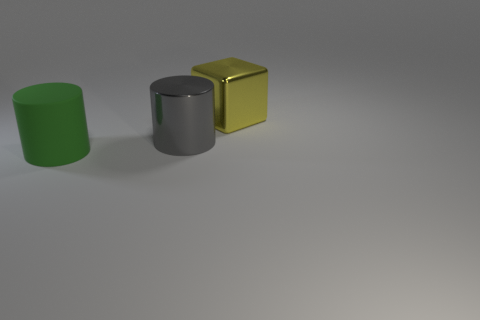There is a metallic object that is in front of the big yellow metal thing; is it the same shape as the big thing on the left side of the large gray cylinder?
Provide a succinct answer. Yes. There is a cylinder behind the rubber thing; what is its size?
Your response must be concise. Large. What size is the shiny thing that is in front of the metal block that is behind the large gray metal cylinder?
Ensure brevity in your answer.  Large. Are there more rubber objects than tiny metal objects?
Provide a succinct answer. Yes. Are there more large yellow things that are right of the green rubber object than large green matte objects behind the large block?
Your answer should be compact. Yes. How many gray objects are the same size as the metallic cube?
Ensure brevity in your answer.  1. There is a big shiny thing in front of the big block; is it the same shape as the green thing?
Provide a succinct answer. Yes. Are there fewer green cylinders that are behind the large gray metallic cylinder than metal things?
Offer a very short reply. Yes. Is there a big rubber cylinder of the same color as the big shiny cylinder?
Provide a succinct answer. No. There is a big green rubber object; does it have the same shape as the big metal thing that is left of the large yellow cube?
Your answer should be compact. Yes. 